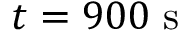<formula> <loc_0><loc_0><loc_500><loc_500>t = 9 0 0 s</formula> 